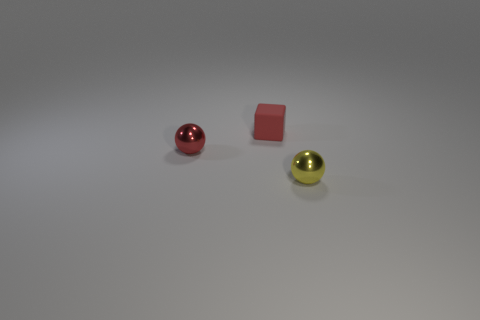Is the number of metallic objects that are left of the red rubber cube greater than the number of tiny shiny cylinders?
Ensure brevity in your answer.  Yes. Do the tiny red ball and the tiny yellow thing have the same material?
Your answer should be compact. Yes. What number of objects are either metal things that are behind the yellow thing or cubes that are on the left side of the tiny yellow metallic ball?
Offer a terse response. 2. What is the color of the other object that is the same shape as the tiny red shiny object?
Make the answer very short. Yellow. What number of things are the same color as the tiny block?
Offer a terse response. 1. What number of things are either tiny balls that are to the left of the yellow sphere or small yellow metal balls?
Your answer should be compact. 2. There is a tiny shiny object behind the tiny thing in front of the tiny metal ball that is on the left side of the yellow thing; what color is it?
Offer a very short reply. Red. There is a thing that is the same material as the yellow sphere; what color is it?
Your response must be concise. Red. How many small red blocks are the same material as the red sphere?
Provide a succinct answer. 0. There is a red ball left of the yellow shiny object; is its size the same as the small yellow metal object?
Ensure brevity in your answer.  Yes. 